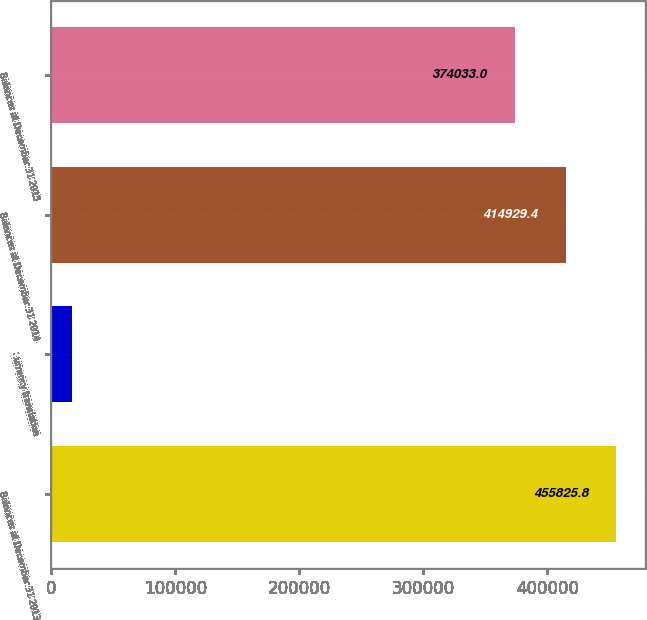Convert chart to OTSL. <chart><loc_0><loc_0><loc_500><loc_500><bar_chart><fcel>Balances at December 31 2013<fcel>Currency translation<fcel>Balances at December 31 2014<fcel>Balances at December 31 2015<nl><fcel>455826<fcel>16537<fcel>414929<fcel>374033<nl></chart> 